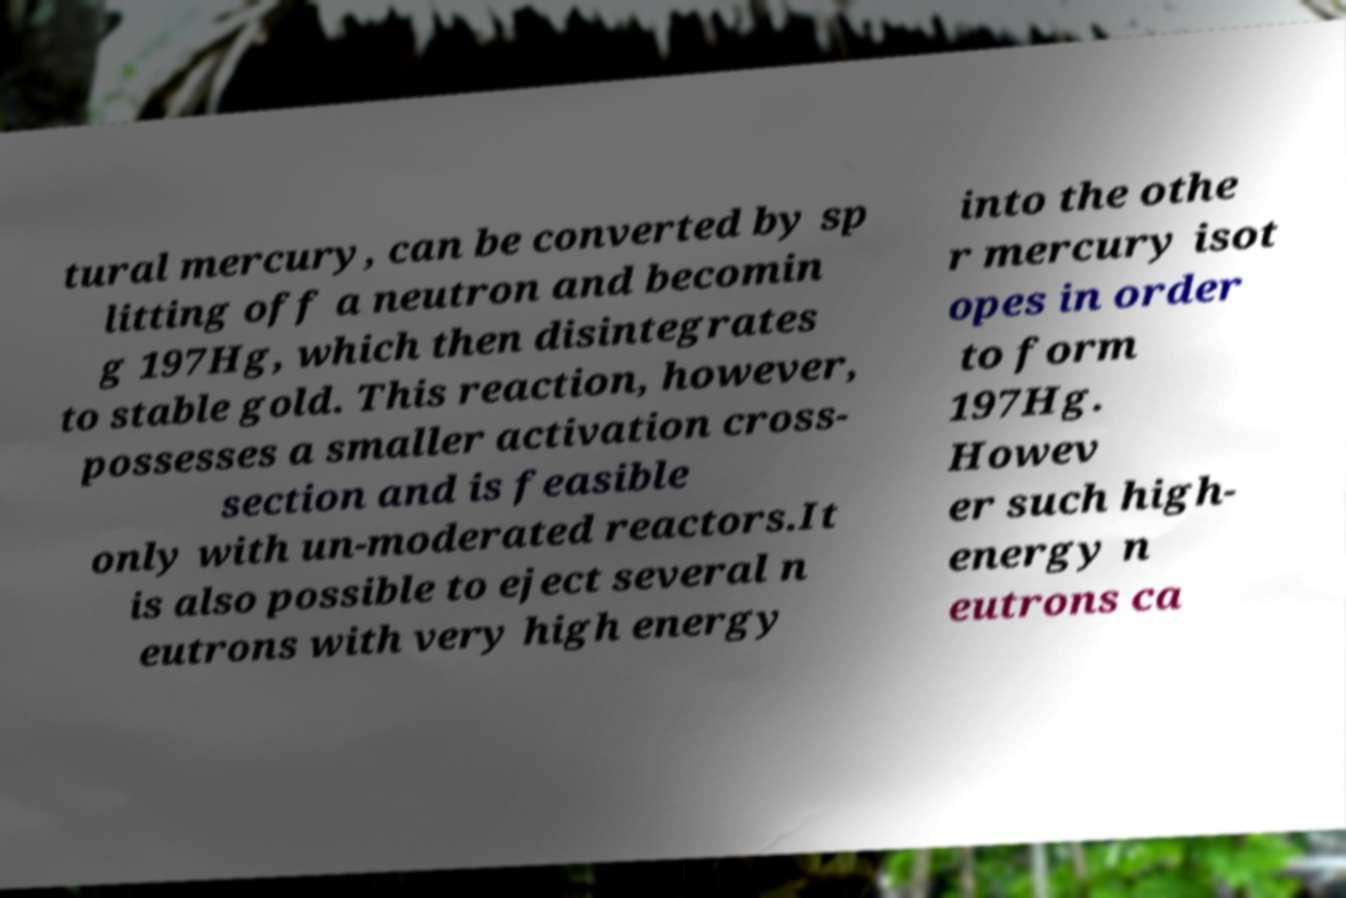Please read and relay the text visible in this image. What does it say? tural mercury, can be converted by sp litting off a neutron and becomin g 197Hg, which then disintegrates to stable gold. This reaction, however, possesses a smaller activation cross- section and is feasible only with un-moderated reactors.It is also possible to eject several n eutrons with very high energy into the othe r mercury isot opes in order to form 197Hg. Howev er such high- energy n eutrons ca 